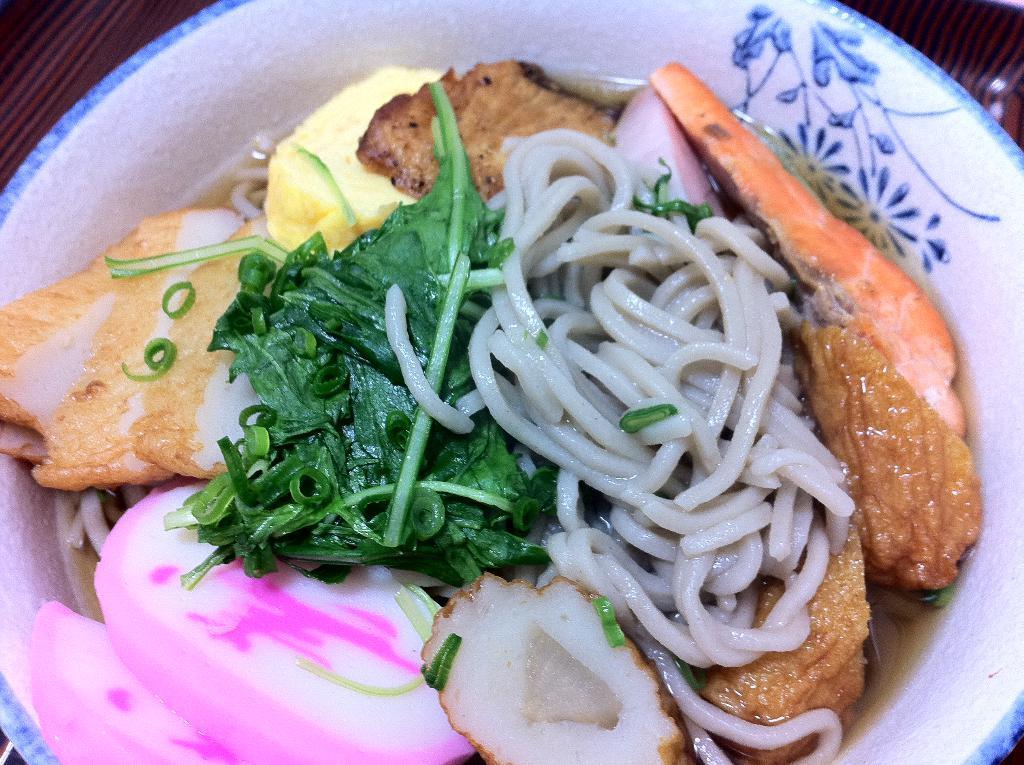In one or two sentences, can you explain what this image depicts? In this image we can see few dishes and vegetables in a bowl, there we can also see a bowl placed on a table. 